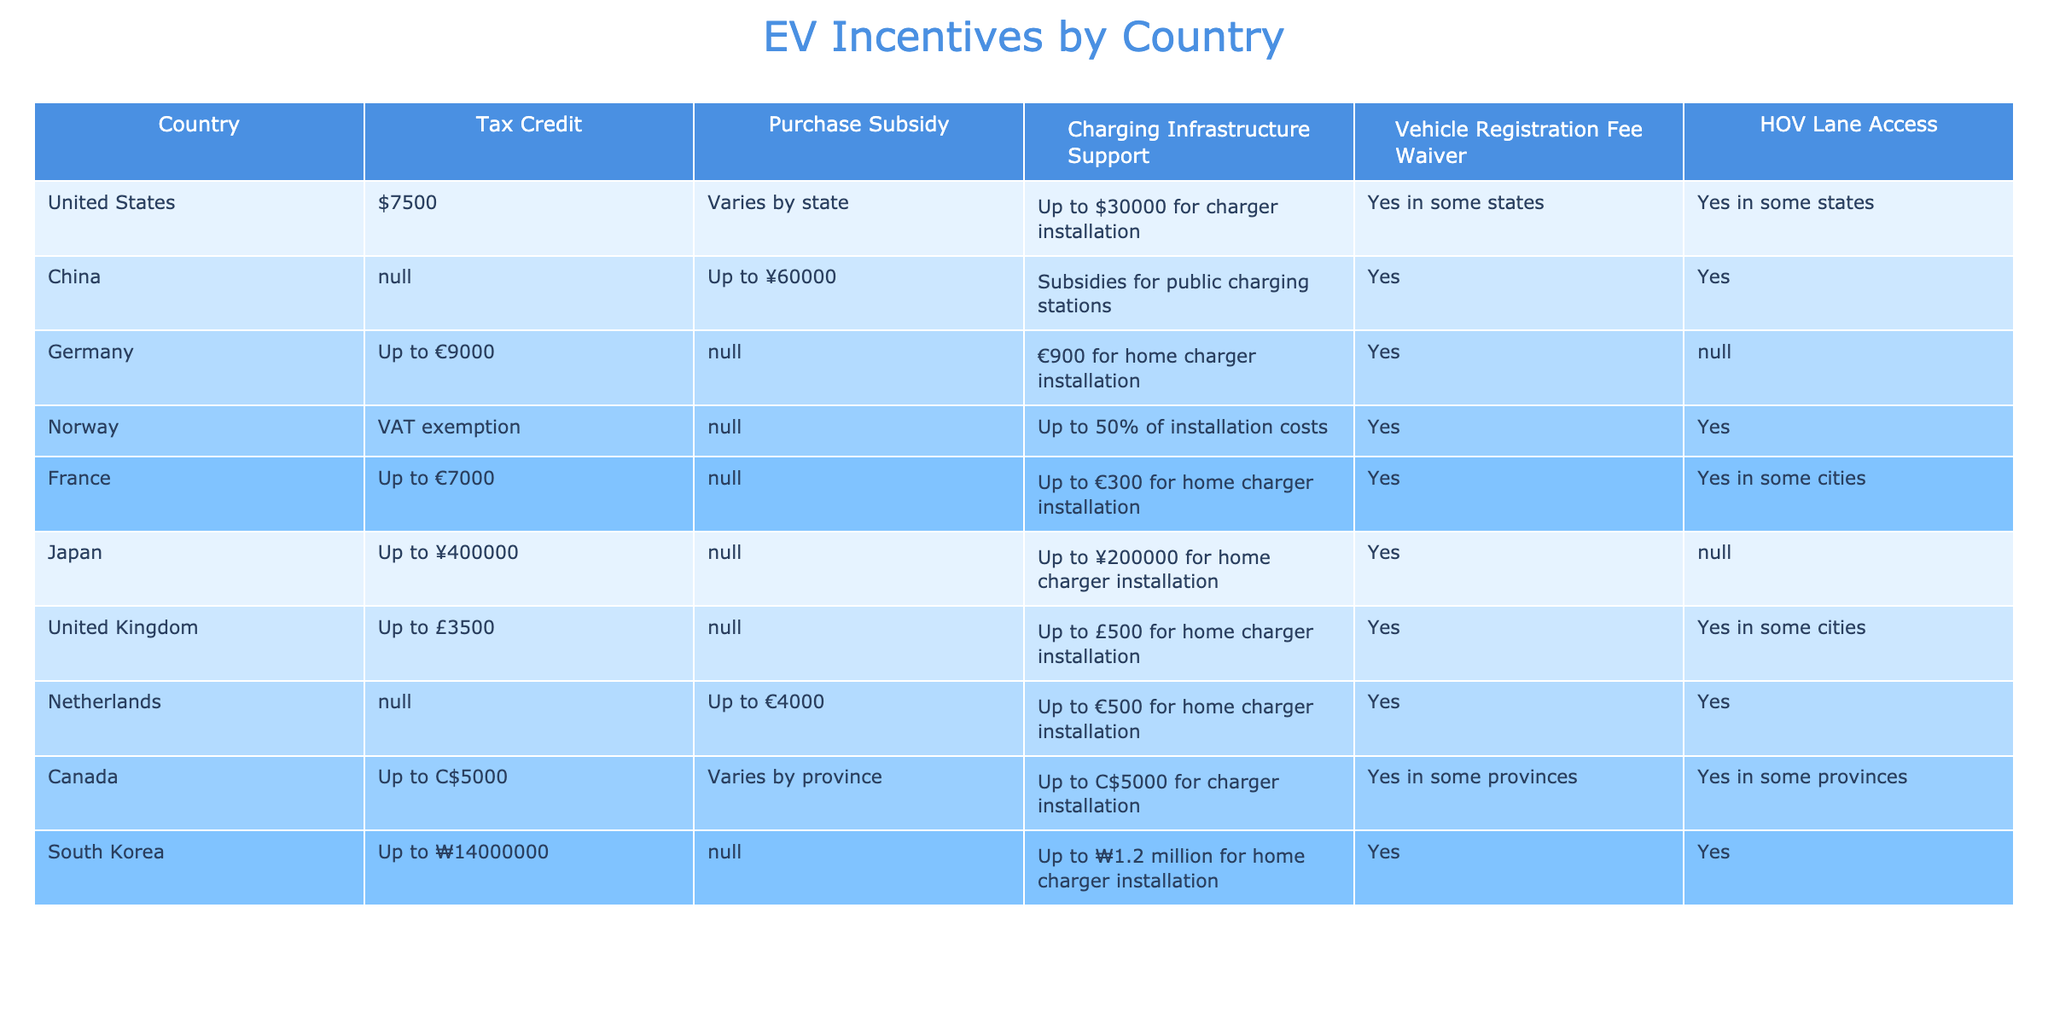What is the tax credit available in the United States for EV purchases? The table states the tax credit for the United States is $7500.
Answer: $7500 Which country offers the highest purchase subsidy for EV purchases? In the table, China offers a purchase subsidy of up to ¥60000, which is higher than any other listed countries.
Answer: ¥60000 Do all countries listed have a vehicle registration fee waiver for EVs? The table indicates that not all countries have a vehicle registration fee waiver; for example, Germany has "N/A" in this category.
Answer: No Which EV incentives are available in Norway? The table shows Norway offers VAT exemption and charging infrastructure support for up to 50% of installation costs, along with a vehicle registration fee waiver.
Answer: VAT exemption and 50% support How many countries provide subsidies for charging infrastructure installation? By counting the "Yes" responses or values in the Charging Infrastructure Support column, we find that 8 out of the 10 listed countries provide subsidies for charging infrastructure installation.
Answer: 8 Which country has both tax credits and purchase subsidies for EVs? In the table, Canada has a tax credit of up to C$5000 and a purchase subsidy that varies by province, making it a country with both types of incentives.
Answer: Canada What is the total amount of vehicle registration fee waivers available among countries that offer them? By summing the vehicle registration fee waivers from the relevant countries (United States + China + Germany + Norway + France + United Kingdom + Netherlands + Canada + South Korea), we note that waiver amounts vary and some are "N/A", so not all can be summed. Thus, total calculation isn't straightforward; only countries with an explicit amount can contribute, but they do not specify.
Answer: Indeterminate In how many countries is HOV lane access guaranteed for EVs? The table shows that 6 countries have HOV lane access ("Yes" indicates guaranteed access) while 3 countries do not specify or have "N/A".
Answer: 6 What is the average tax credit value available across all listed countries? Calculating the average involves only countries with stated values: ($7500 + €9000 + ¥400000 + Up to £3500 + Up to C$5000 + Up to ₩14000000) converted to a common currency, leading to a multi-step calculation. Exact value depends on exchange rates not provided, hence can't summarize directly.
Answer: Indeterminate Which countries offer both charging infrastructure support and vehicle registration fee waiver? According to the table, the countries that offer both advantages are the United States, China, Norway, France, the United Kingdom, Canada, and South Korea.
Answer: 7 countries 